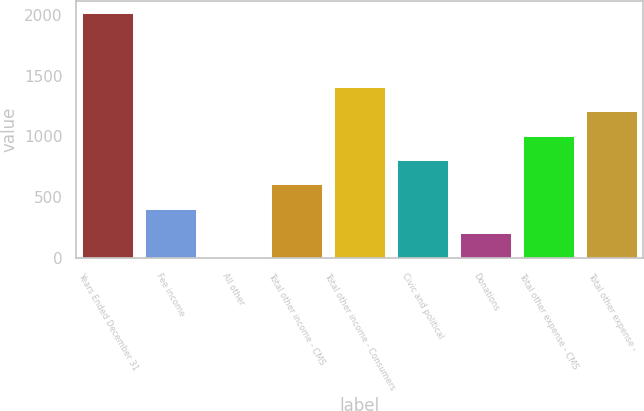Convert chart. <chart><loc_0><loc_0><loc_500><loc_500><bar_chart><fcel>Years Ended December 31<fcel>Fee income<fcel>All other<fcel>Total other income - CMS<fcel>Total other income - Consumers<fcel>Civic and political<fcel>Donations<fcel>Total other expense - CMS<fcel>Total other expense -<nl><fcel>2015<fcel>403.8<fcel>1<fcel>605.2<fcel>1410.8<fcel>806.6<fcel>202.4<fcel>1008<fcel>1209.4<nl></chart> 